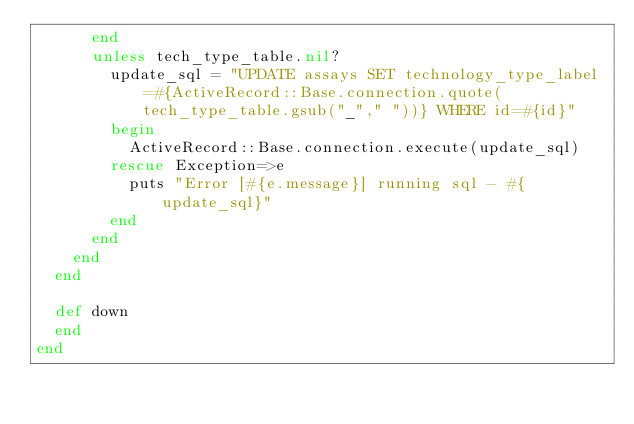<code> <loc_0><loc_0><loc_500><loc_500><_Ruby_>      end
      unless tech_type_table.nil?
        update_sql = "UPDATE assays SET technology_type_label=#{ActiveRecord::Base.connection.quote(tech_type_table.gsub("_"," "))} WHERE id=#{id}"
        begin
          ActiveRecord::Base.connection.execute(update_sql)
        rescue Exception=>e
          puts "Error [#{e.message}] running sql - #{update_sql}"
        end
      end
    end
  end

  def down
  end
end
</code> 